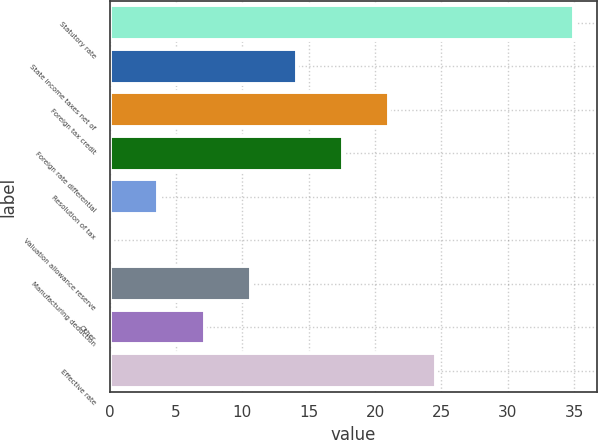Convert chart. <chart><loc_0><loc_0><loc_500><loc_500><bar_chart><fcel>Statutory rate<fcel>State income taxes net of<fcel>Foreign tax credit<fcel>Foreign rate differential<fcel>Resolution of tax<fcel>Valuation allowance reserve<fcel>Manufacturing deduction<fcel>Other<fcel>Effective rate<nl><fcel>35<fcel>14.12<fcel>21.08<fcel>17.6<fcel>3.68<fcel>0.2<fcel>10.64<fcel>7.16<fcel>24.56<nl></chart> 